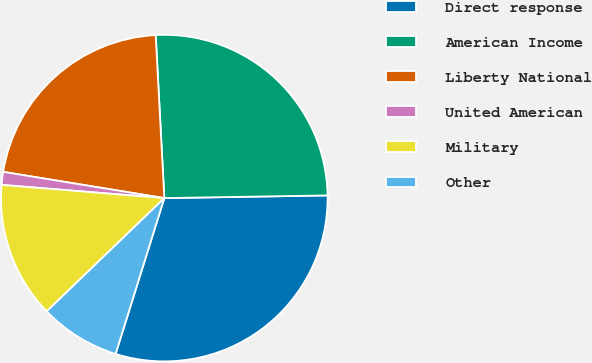Convert chart to OTSL. <chart><loc_0><loc_0><loc_500><loc_500><pie_chart><fcel>Direct response<fcel>American Income<fcel>Liberty National<fcel>United American<fcel>Military<fcel>Other<nl><fcel>30.09%<fcel>25.58%<fcel>21.59%<fcel>1.28%<fcel>13.49%<fcel>7.98%<nl></chart> 